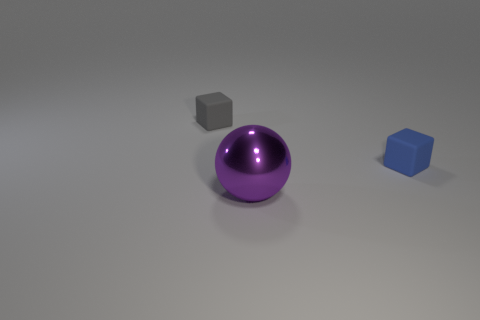What number of other things are there of the same size as the gray matte thing?
Make the answer very short. 1. Are there fewer rubber things behind the tiny gray cube than tiny matte objects that are behind the purple ball?
Make the answer very short. Yes. The thing that is behind the big metal object and in front of the gray rubber thing is what color?
Ensure brevity in your answer.  Blue. Does the blue rubber cube have the same size as the purple metal thing that is in front of the blue block?
Keep it short and to the point. No. What shape is the small rubber thing to the right of the large purple object?
Ensure brevity in your answer.  Cube. Is there anything else that is made of the same material as the large object?
Your answer should be very brief. No. Are there more objects that are to the right of the large metallic thing than large purple shiny cylinders?
Make the answer very short. Yes. There is a cube that is to the left of the tiny thing that is on the right side of the purple ball; how many blue cubes are behind it?
Give a very brief answer. 0. There is a matte block left of the large purple object; is it the same size as the rubber thing in front of the gray object?
Make the answer very short. Yes. What material is the tiny block that is in front of the matte block that is on the left side of the tiny blue block made of?
Provide a short and direct response. Rubber. 